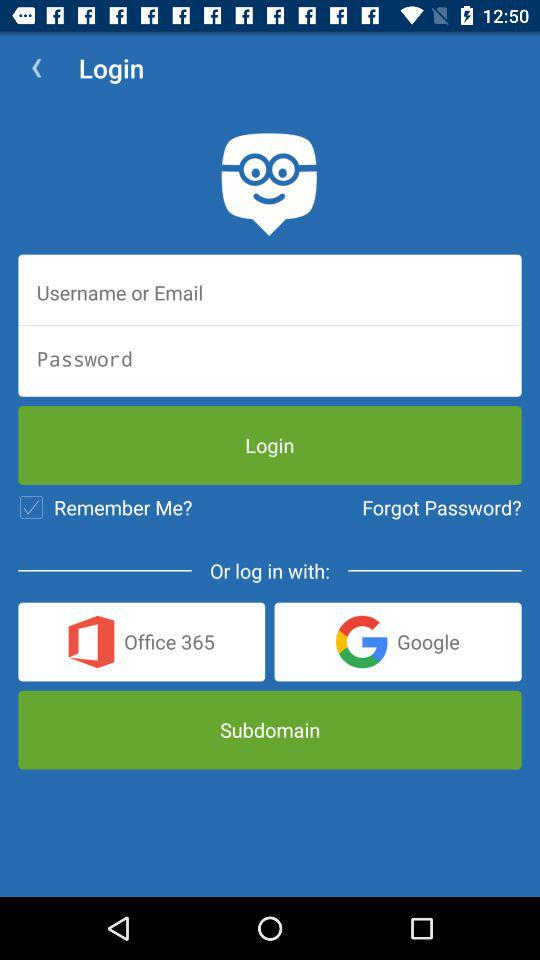What is the status of "Remember Me"? The status is "on". 